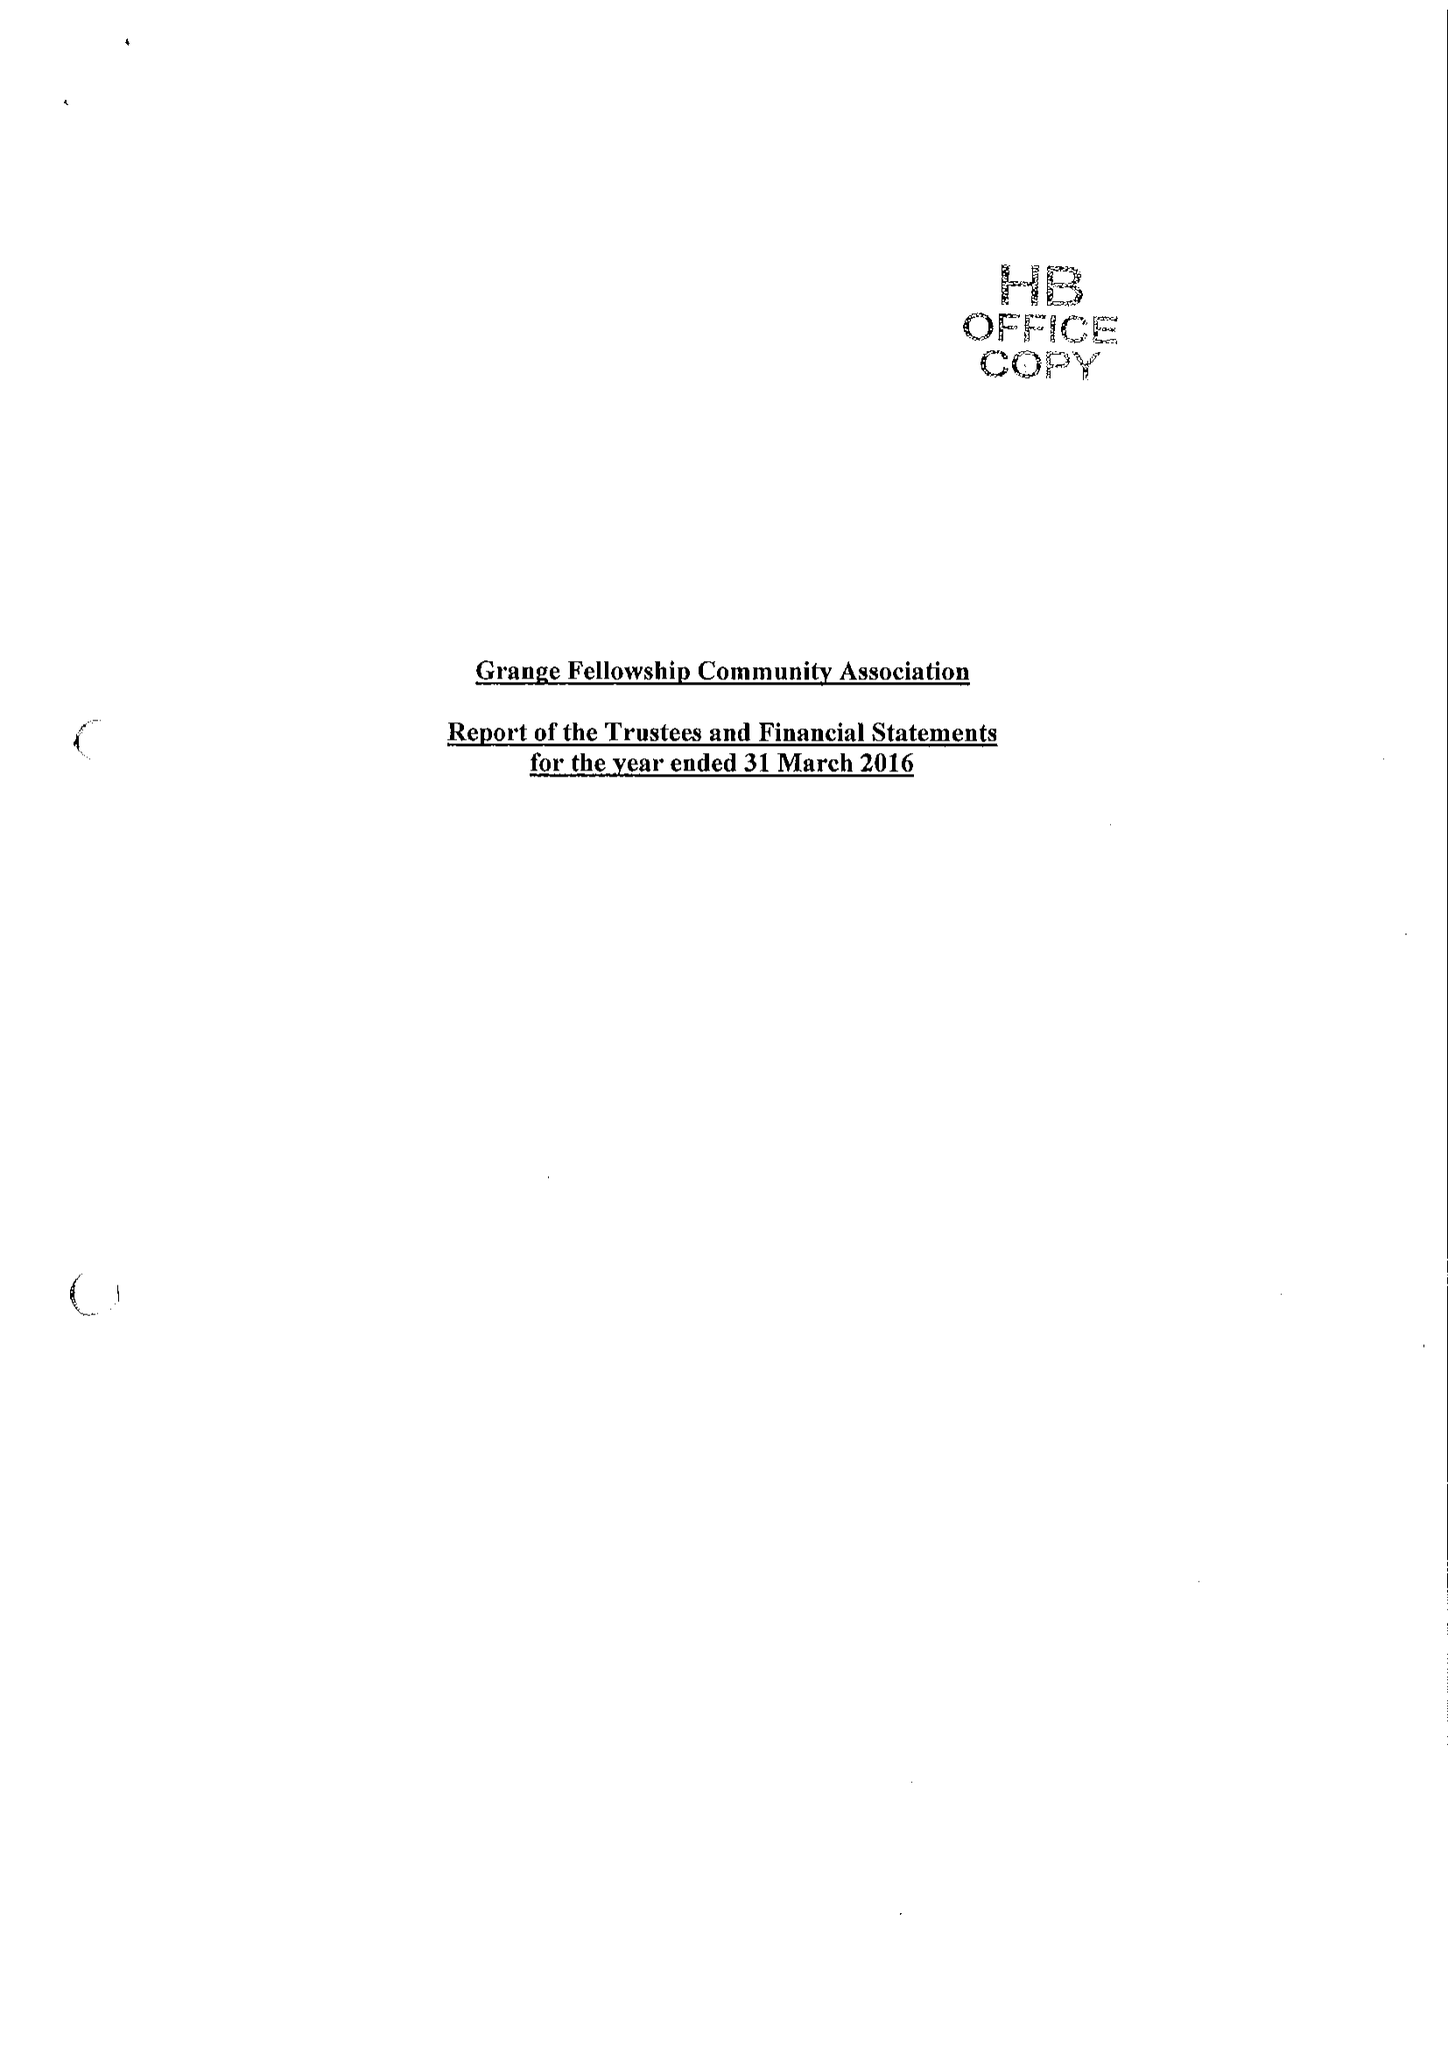What is the value for the report_date?
Answer the question using a single word or phrase. 2016-03-31 